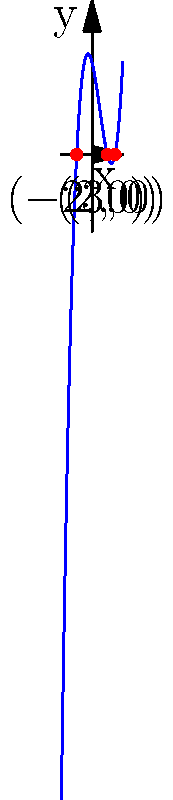Given the graph of the cubic polynomial $f(x)$ shown above, determine the roots of the equation $f(x) = 0$. What is the sum of these roots? To solve this problem, we'll follow these steps:

1) First, we need to identify the roots of the polynomial from the graph. The roots are the x-coordinates of the points where the curve intersects the x-axis.

2) From the graph, we can see that the curve intersects the x-axis at three points:
   $x = -2$, $x = 2$, and $x = 3$

3) These x-values are the roots of the polynomial equation $f(x) = 0$

4) To find the sum of the roots, we simply add these values:

   $(-2) + 2 + 3 = 3$

5) We can verify this result using Vieta's formulas. For a cubic equation $ax^3 + bx^2 + cx + d = 0$, the sum of the roots is given by $-\frac{b}{a}$. 

   In this case, the polynomial appears to be of the form $x^3 - 3x^2 - 4x + 12 = 0$

   So, $a = 1$ and $b = -3$

   $-\frac{b}{a} = -\frac{-3}{1} = 3$

This confirms our graphical solution.
Answer: 3 